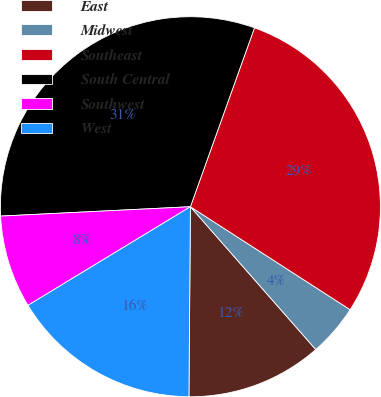<chart> <loc_0><loc_0><loc_500><loc_500><pie_chart><fcel>East<fcel>Midwest<fcel>Southeast<fcel>South Central<fcel>Southwest<fcel>West<nl><fcel>11.59%<fcel>4.42%<fcel>28.64%<fcel>31.26%<fcel>7.9%<fcel>16.19%<nl></chart> 